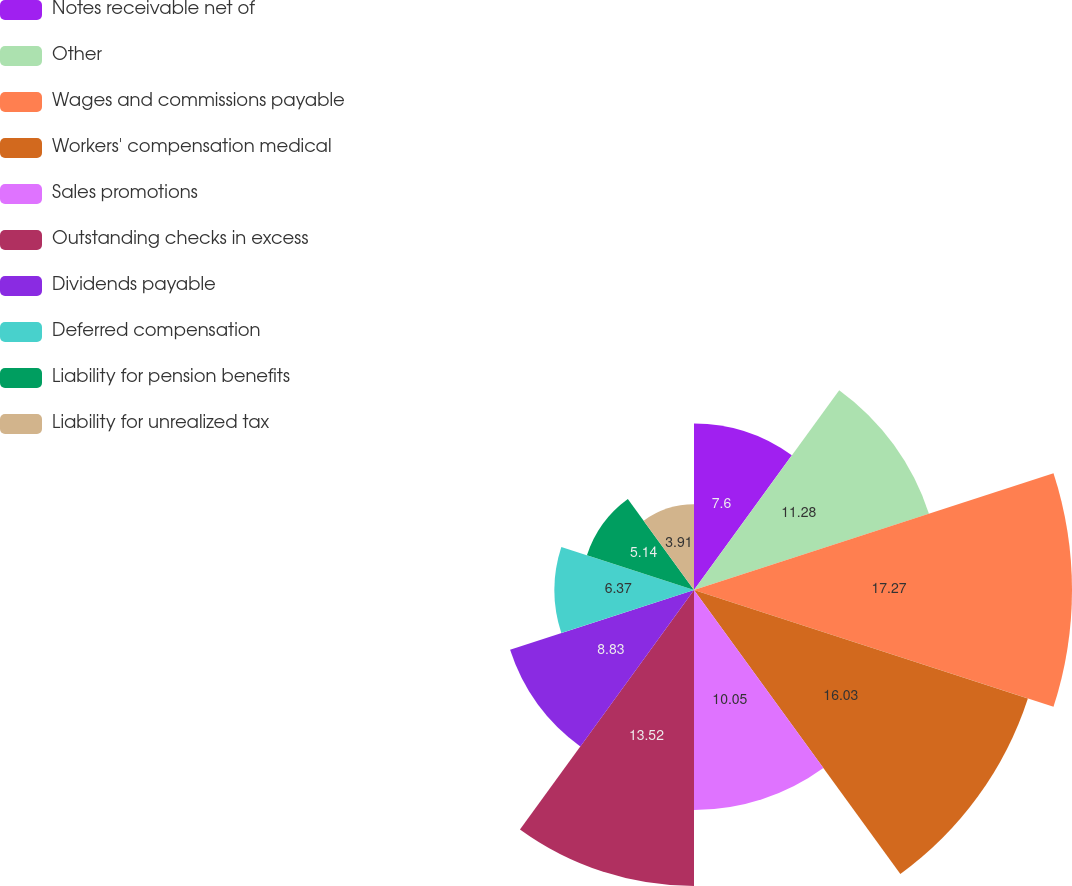Convert chart to OTSL. <chart><loc_0><loc_0><loc_500><loc_500><pie_chart><fcel>Notes receivable net of<fcel>Other<fcel>Wages and commissions payable<fcel>Workers' compensation medical<fcel>Sales promotions<fcel>Outstanding checks in excess<fcel>Dividends payable<fcel>Deferred compensation<fcel>Liability for pension benefits<fcel>Liability for unrealized tax<nl><fcel>7.6%<fcel>11.28%<fcel>17.26%<fcel>16.03%<fcel>10.05%<fcel>13.52%<fcel>8.83%<fcel>6.37%<fcel>5.14%<fcel>3.91%<nl></chart> 